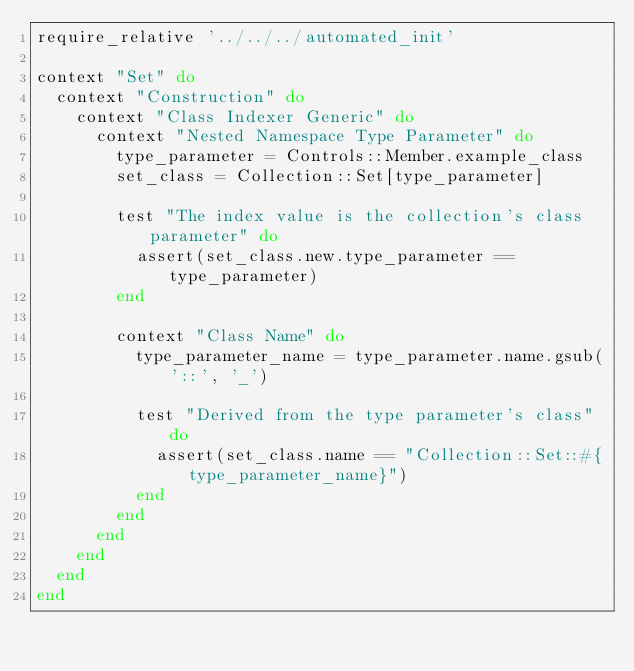Convert code to text. <code><loc_0><loc_0><loc_500><loc_500><_Ruby_>require_relative '../../../automated_init'

context "Set" do
  context "Construction" do
    context "Class Indexer Generic" do
      context "Nested Namespace Type Parameter" do
        type_parameter = Controls::Member.example_class
        set_class = Collection::Set[type_parameter]

        test "The index value is the collection's class parameter" do
          assert(set_class.new.type_parameter == type_parameter)
        end

        context "Class Name" do
          type_parameter_name = type_parameter.name.gsub('::', '_')

          test "Derived from the type parameter's class" do
            assert(set_class.name == "Collection::Set::#{type_parameter_name}")
          end
        end
      end
    end
  end
end
</code> 